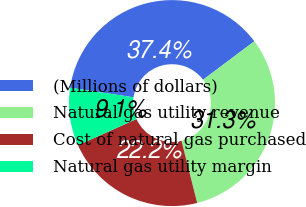Convert chart. <chart><loc_0><loc_0><loc_500><loc_500><pie_chart><fcel>(Millions of dollars)<fcel>Natural gas utility revenue<fcel>Cost of natural gas purchased<fcel>Natural gas utility margin<nl><fcel>37.38%<fcel>31.31%<fcel>22.22%<fcel>9.09%<nl></chart> 